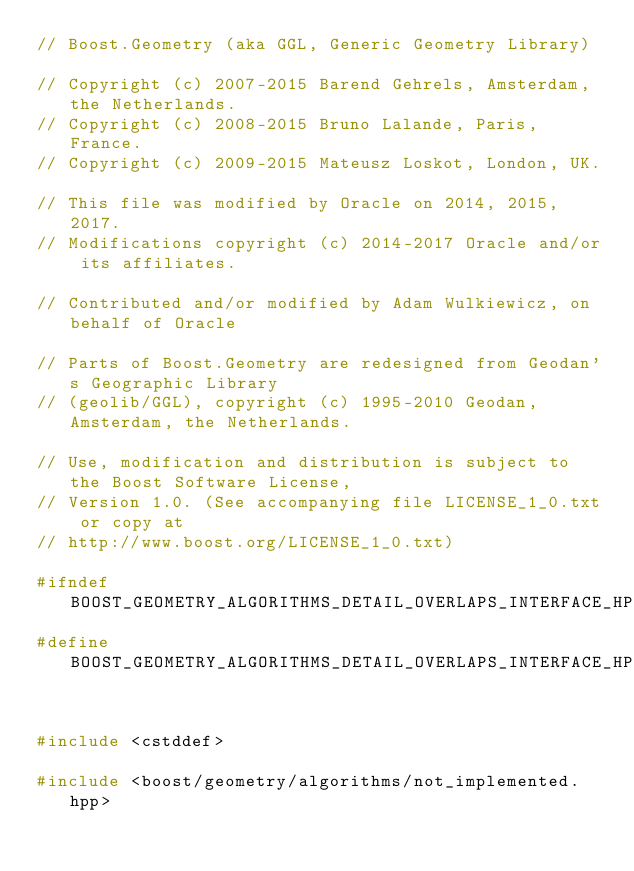Convert code to text. <code><loc_0><loc_0><loc_500><loc_500><_C++_>// Boost.Geometry (aka GGL, Generic Geometry Library)

// Copyright (c) 2007-2015 Barend Gehrels, Amsterdam, the Netherlands.
// Copyright (c) 2008-2015 Bruno Lalande, Paris, France.
// Copyright (c) 2009-2015 Mateusz Loskot, London, UK.

// This file was modified by Oracle on 2014, 2015, 2017.
// Modifications copyright (c) 2014-2017 Oracle and/or its affiliates.

// Contributed and/or modified by Adam Wulkiewicz, on behalf of Oracle

// Parts of Boost.Geometry are redesigned from Geodan's Geographic Library
// (geolib/GGL), copyright (c) 1995-2010 Geodan, Amsterdam, the Netherlands.

// Use, modification and distribution is subject to the Boost Software License,
// Version 1.0. (See accompanying file LICENSE_1_0.txt or copy at
// http://www.boost.org/LICENSE_1_0.txt)

#ifndef BOOST_GEOMETRY_ALGORITHMS_DETAIL_OVERLAPS_INTERFACE_HPP
#define BOOST_GEOMETRY_ALGORITHMS_DETAIL_OVERLAPS_INTERFACE_HPP


#include <cstddef>

#include <boost/geometry/algorithms/not_implemented.hpp>
</code> 